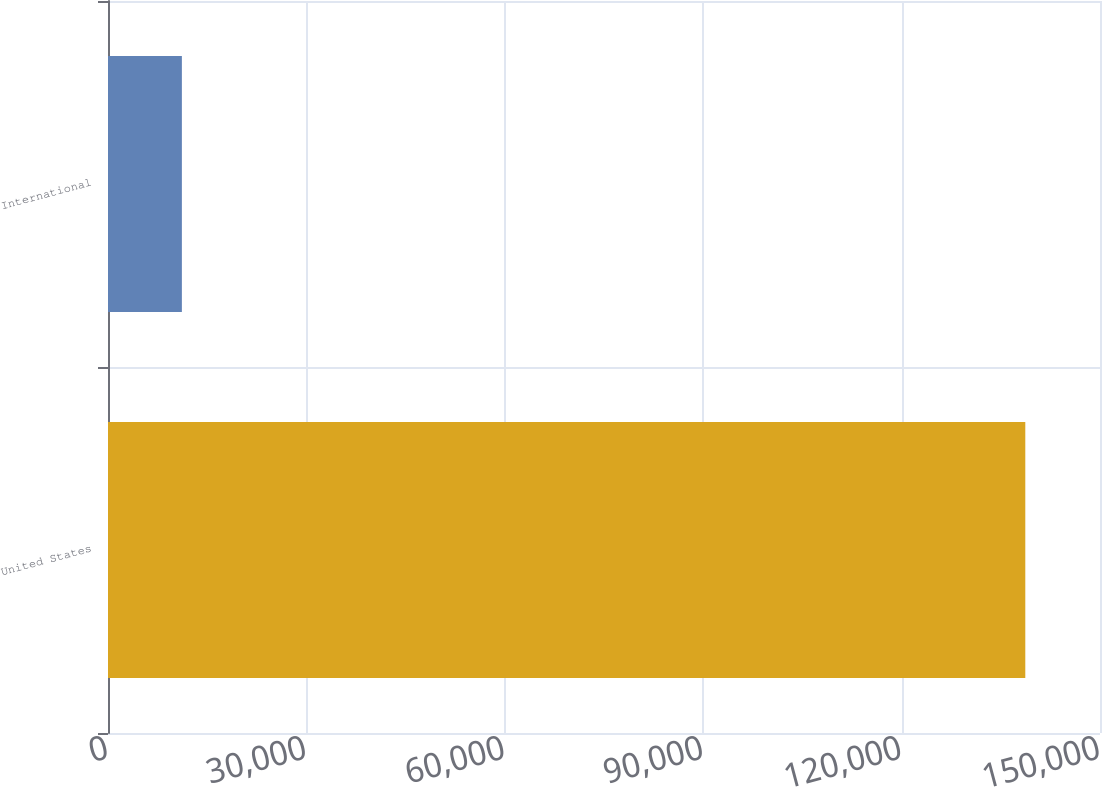<chart> <loc_0><loc_0><loc_500><loc_500><bar_chart><fcel>United States<fcel>International<nl><fcel>138704<fcel>11171<nl></chart> 